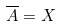Convert formula to latex. <formula><loc_0><loc_0><loc_500><loc_500>\overline { A } = X</formula> 